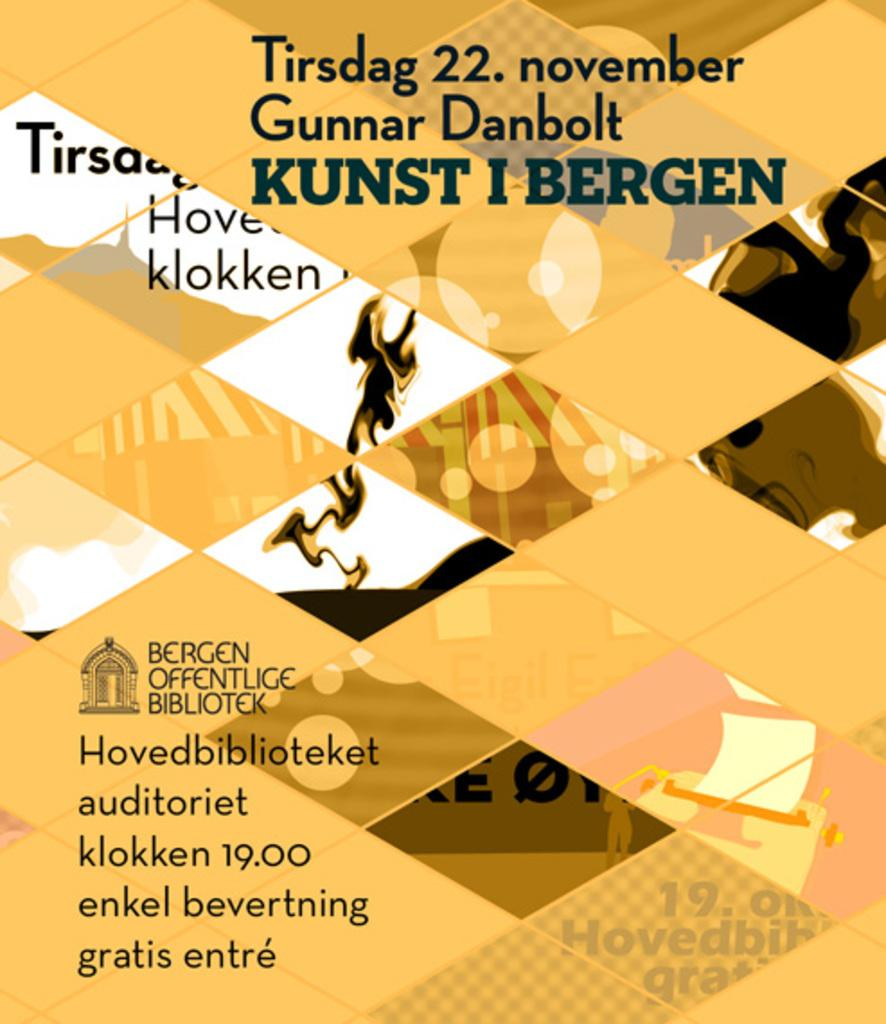Provide a one-sentence caption for the provided image. A yellow colored paper with German writing on it that mentions the date of November 22. 